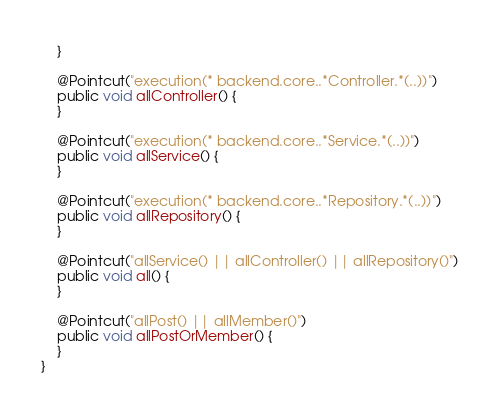<code> <loc_0><loc_0><loc_500><loc_500><_Java_>    }

    @Pointcut("execution(* backend.core..*Controller.*(..))")
    public void allController() {
    }

    @Pointcut("execution(* backend.core..*Service.*(..))")
    public void allService() {
    }

    @Pointcut("execution(* backend.core..*Repository.*(..))")
    public void allRepository() {
    }

    @Pointcut("allService() || allController() || allRepository()")
    public void all() {
    }

    @Pointcut("allPost() || allMember()")
    public void allPostOrMember() {
    }
}
</code> 